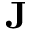<formula> <loc_0><loc_0><loc_500><loc_500>J</formula> 